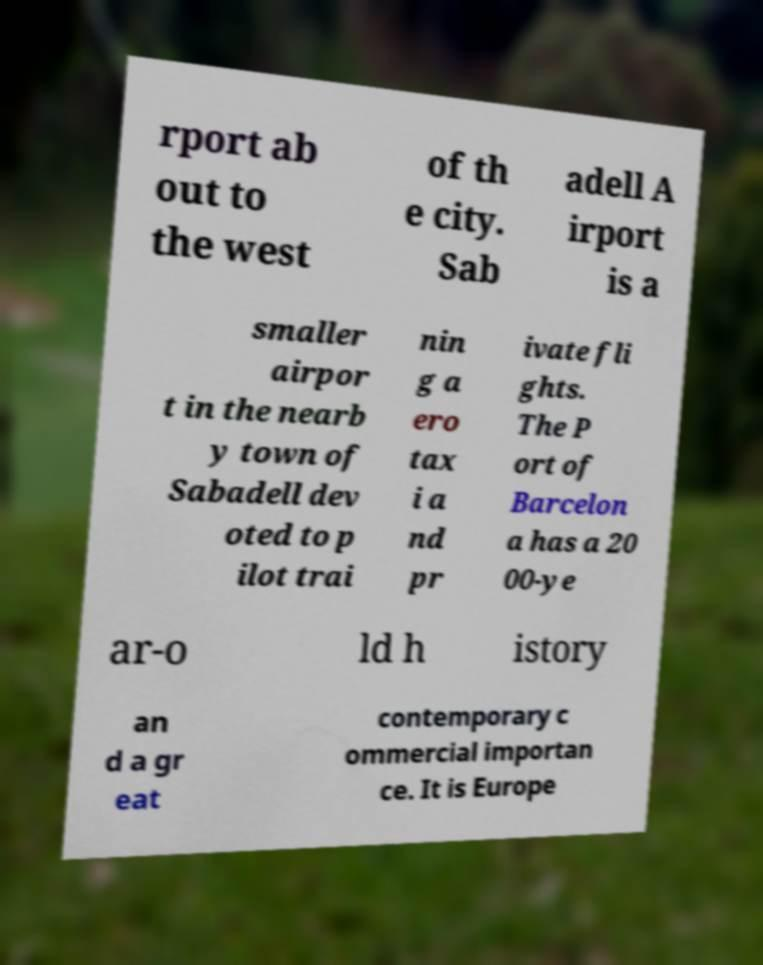Could you extract and type out the text from this image? rport ab out to the west of th e city. Sab adell A irport is a smaller airpor t in the nearb y town of Sabadell dev oted to p ilot trai nin g a ero tax i a nd pr ivate fli ghts. The P ort of Barcelon a has a 20 00-ye ar-o ld h istory an d a gr eat contemporary c ommercial importan ce. It is Europe 